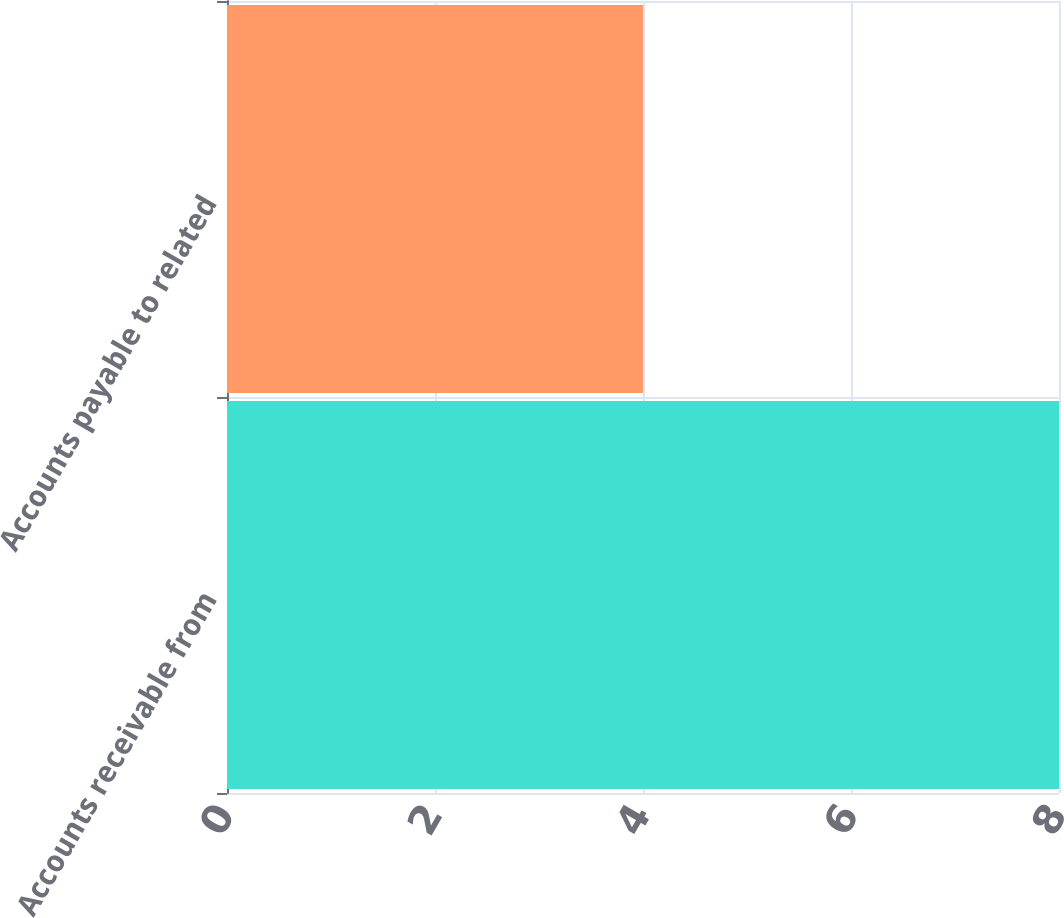Convert chart to OTSL. <chart><loc_0><loc_0><loc_500><loc_500><bar_chart><fcel>Accounts receivable from<fcel>Accounts payable to related<nl><fcel>8<fcel>4<nl></chart> 